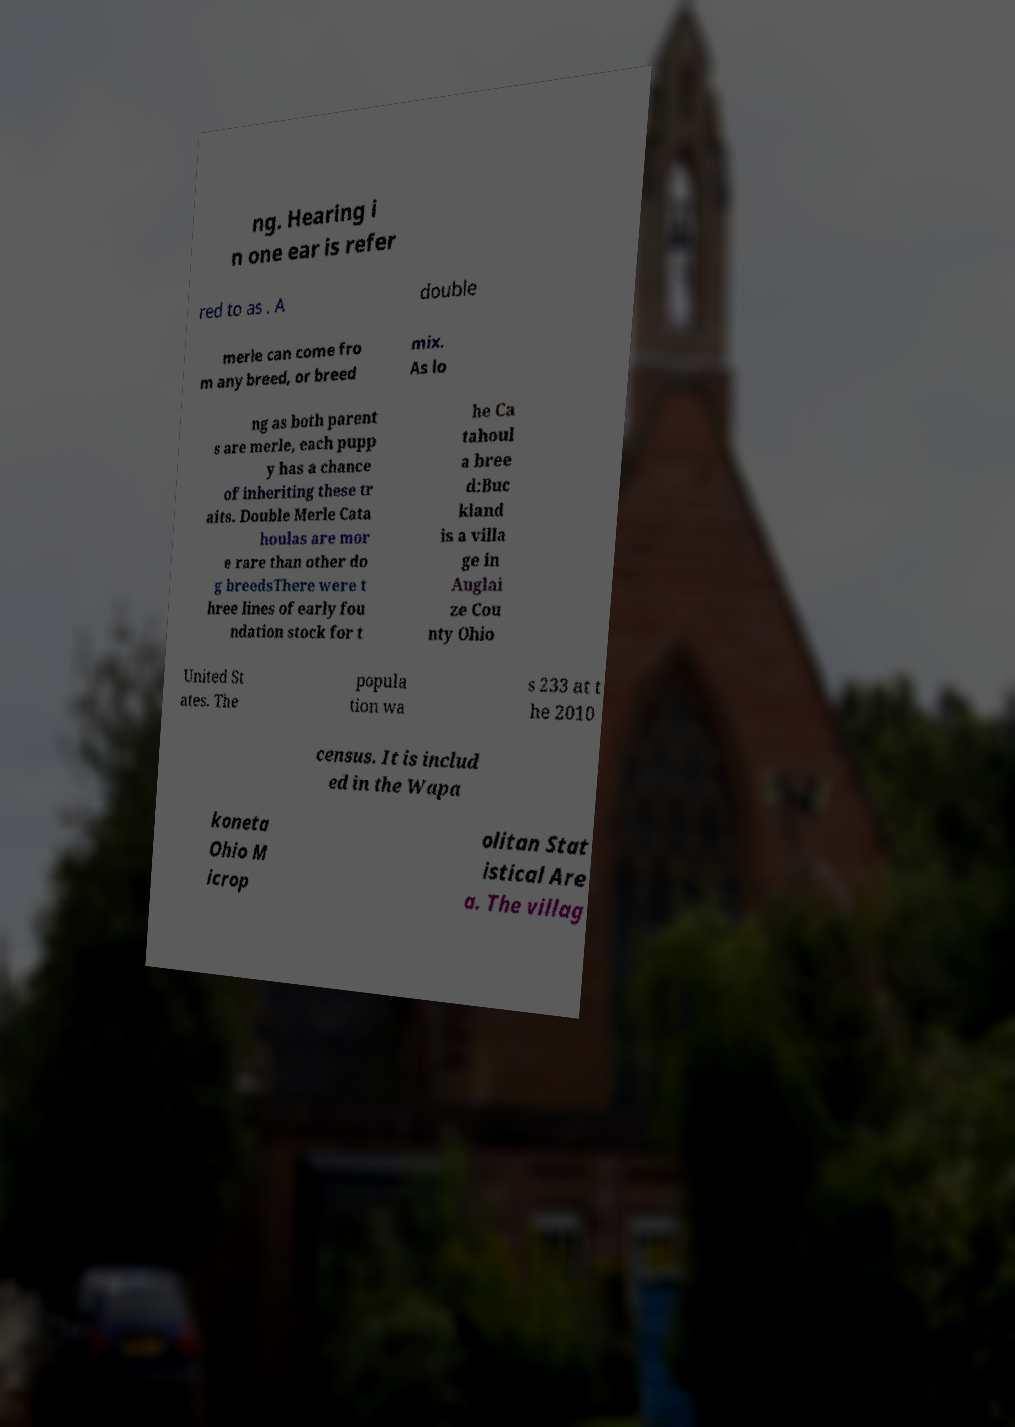Could you assist in decoding the text presented in this image and type it out clearly? ng. Hearing i n one ear is refer red to as . A double merle can come fro m any breed, or breed mix. As lo ng as both parent s are merle, each pupp y has a chance of inheriting these tr aits. Double Merle Cata houlas are mor e rare than other do g breedsThere were t hree lines of early fou ndation stock for t he Ca tahoul a bree d:Buc kland is a villa ge in Auglai ze Cou nty Ohio United St ates. The popula tion wa s 233 at t he 2010 census. It is includ ed in the Wapa koneta Ohio M icrop olitan Stat istical Are a. The villag 